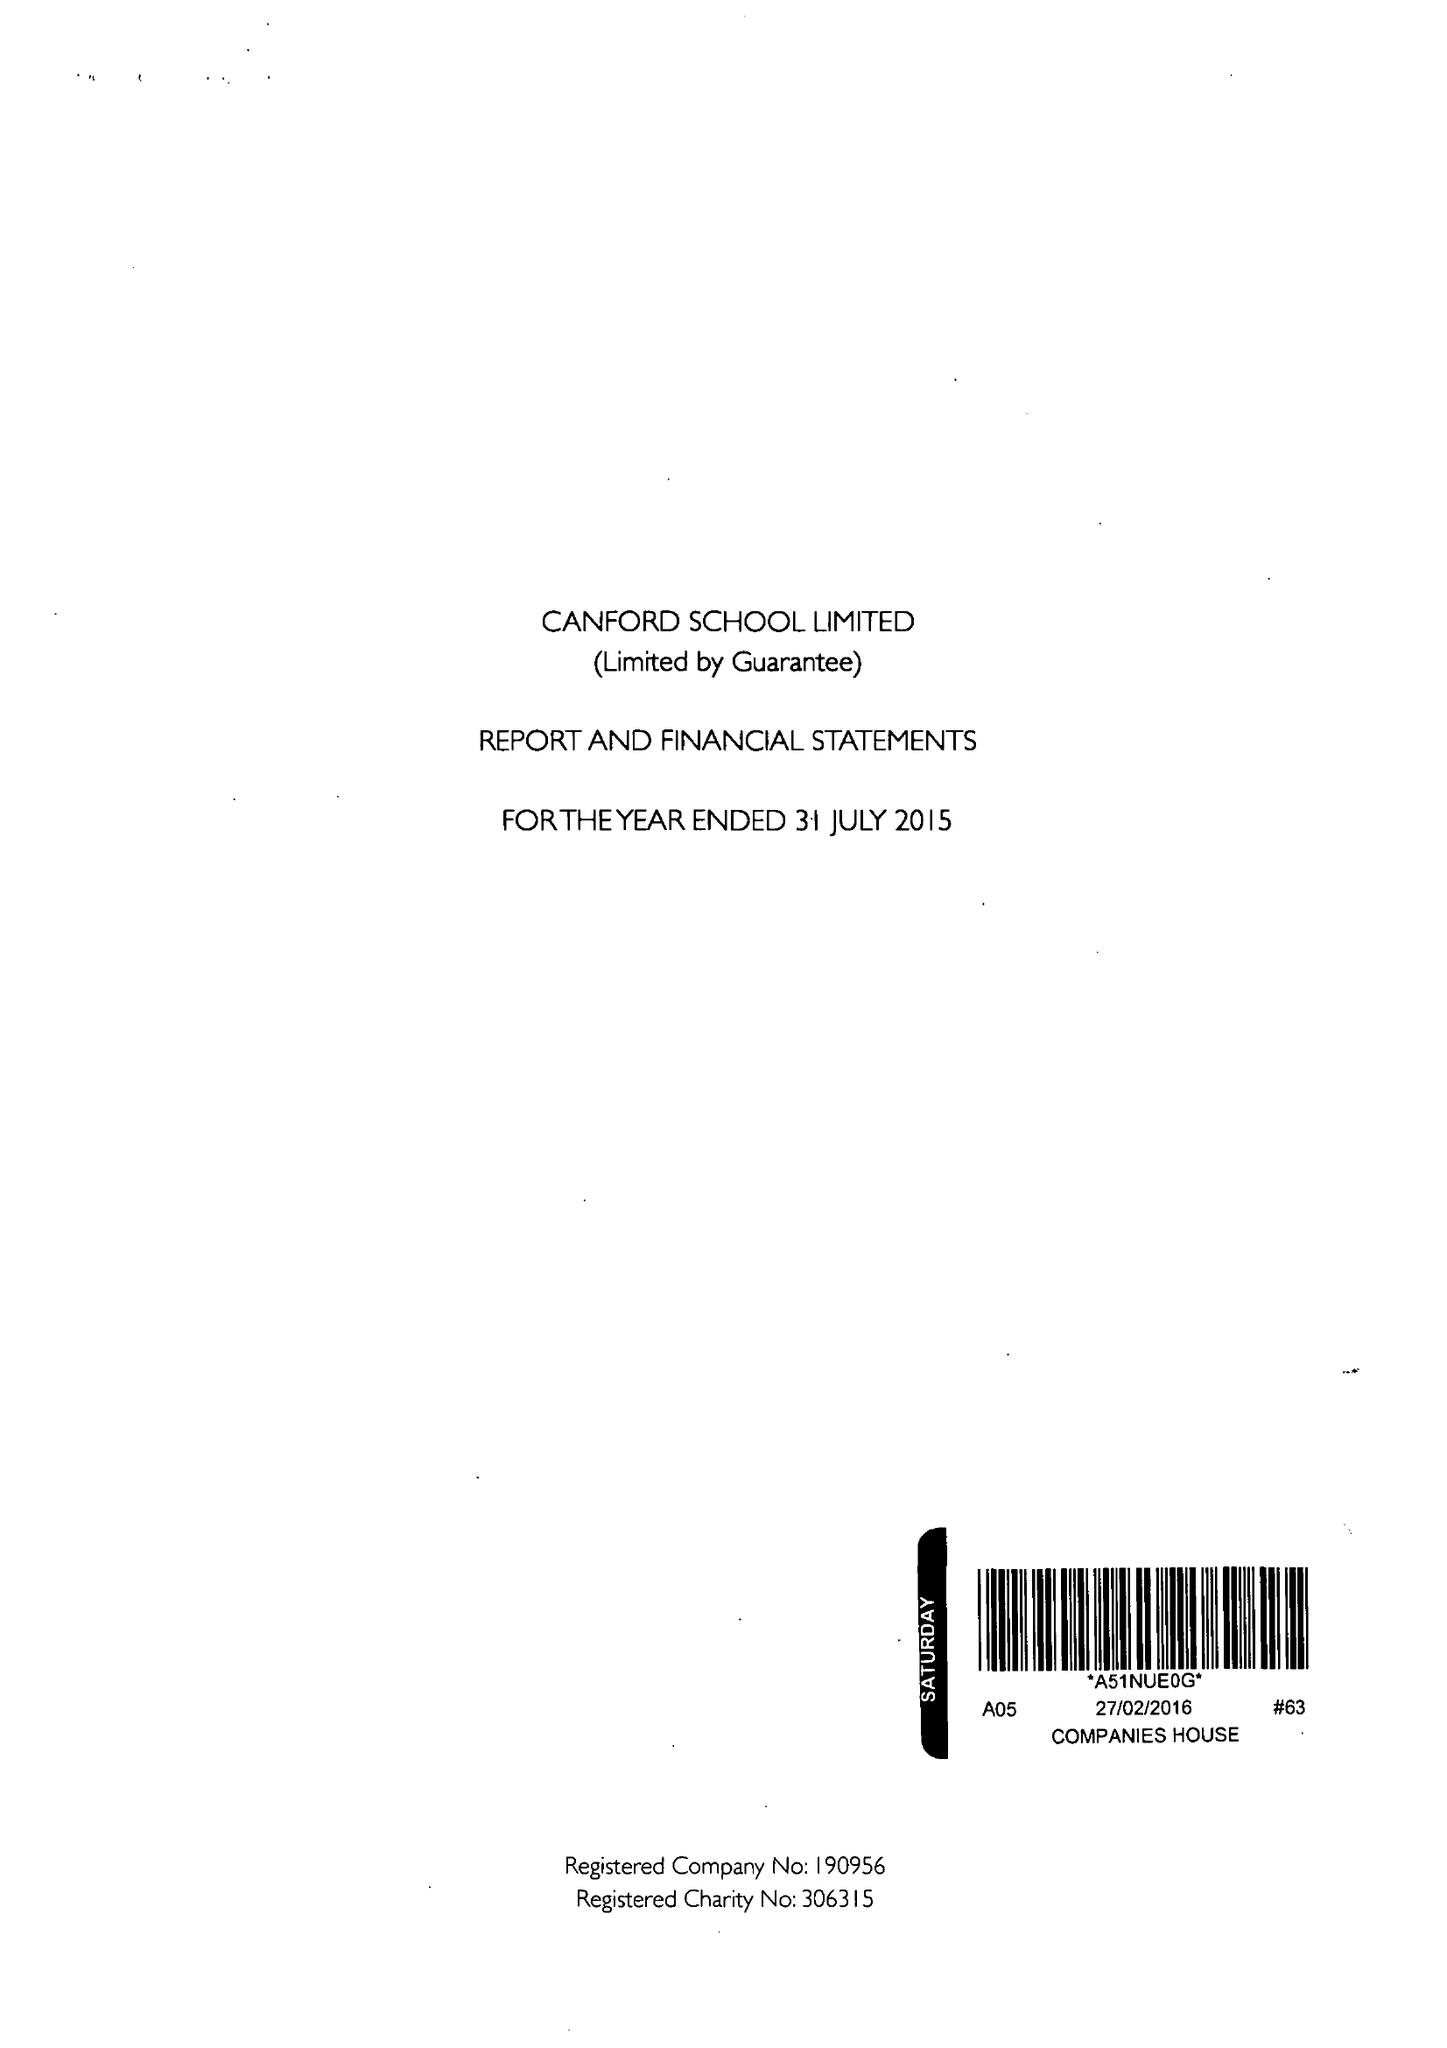What is the value for the address__postcode?
Answer the question using a single word or phrase. BH21 3AD 